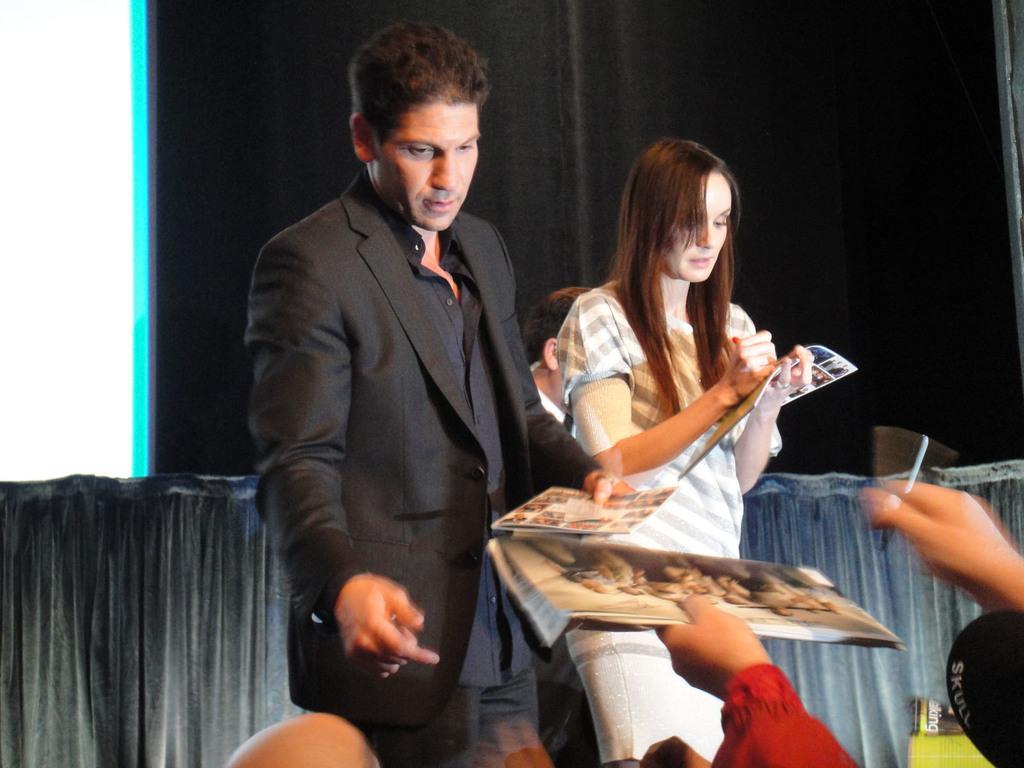Can you describe this image briefly? In this picture I can see a man and a woman standing and holding books, there are hands of a person holding a book and a pen, and in the background there are curtains. 